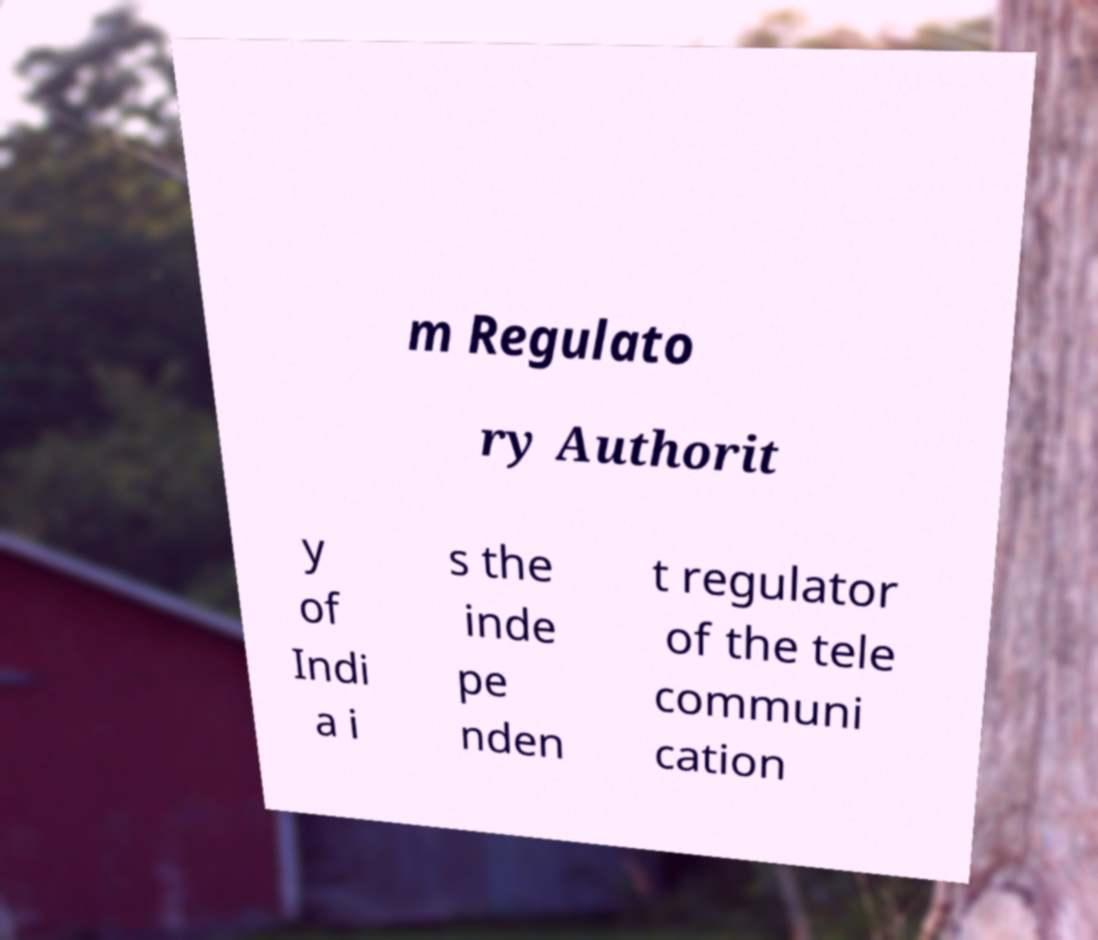Please read and relay the text visible in this image. What does it say? m Regulato ry Authorit y of Indi a i s the inde pe nden t regulator of the tele communi cation 